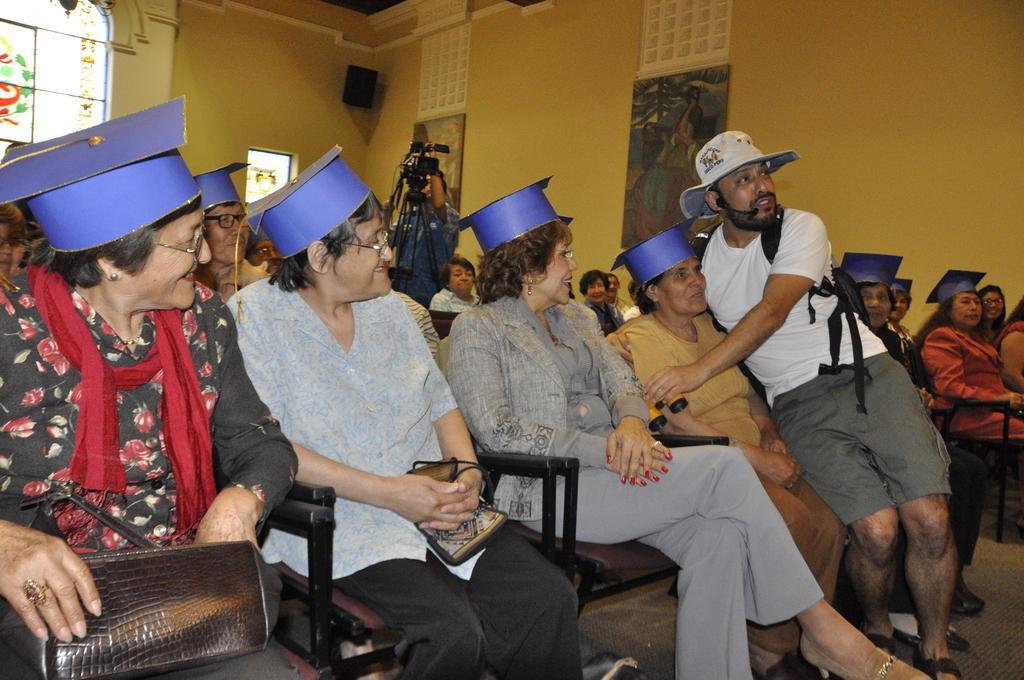Describe this image in one or two sentences. In this picture, we see many people are sitting on the chairs. All of them are wearing the blue color caps. The woman on the left side is holding a handbag. The man in the white T-shirt is wearing a black backpack and a white hat. He might be talking on the microphone. On the right side, we see the women are sitting on the chairs. In the middle, we see a camera stand and beside that, we see a man in the blue shirt is standing. In the background, we see the window, door and a wall on which the photo frames are placed. 